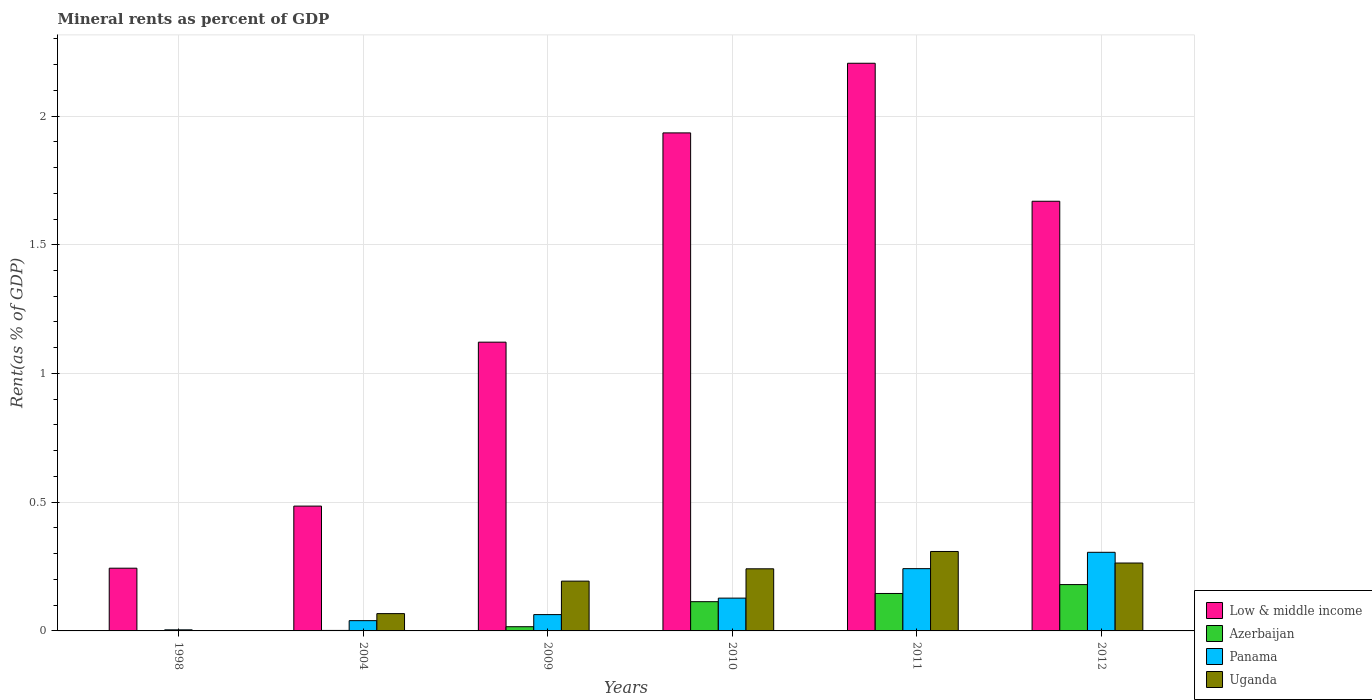Are the number of bars per tick equal to the number of legend labels?
Your answer should be compact. Yes. Are the number of bars on each tick of the X-axis equal?
Your response must be concise. Yes. How many bars are there on the 3rd tick from the left?
Give a very brief answer. 4. What is the label of the 1st group of bars from the left?
Your answer should be compact. 1998. What is the mineral rent in Low & middle income in 2004?
Give a very brief answer. 0.48. Across all years, what is the maximum mineral rent in Panama?
Make the answer very short. 0.31. Across all years, what is the minimum mineral rent in Low & middle income?
Keep it short and to the point. 0.24. What is the total mineral rent in Azerbaijan in the graph?
Keep it short and to the point. 0.46. What is the difference between the mineral rent in Azerbaijan in 2004 and that in 2010?
Your answer should be very brief. -0.11. What is the difference between the mineral rent in Uganda in 2011 and the mineral rent in Low & middle income in 2012?
Keep it short and to the point. -1.36. What is the average mineral rent in Azerbaijan per year?
Provide a succinct answer. 0.08. In the year 2010, what is the difference between the mineral rent in Azerbaijan and mineral rent in Panama?
Give a very brief answer. -0.01. What is the ratio of the mineral rent in Azerbaijan in 2009 to that in 2010?
Provide a succinct answer. 0.14. Is the difference between the mineral rent in Azerbaijan in 1998 and 2010 greater than the difference between the mineral rent in Panama in 1998 and 2010?
Your response must be concise. Yes. What is the difference between the highest and the second highest mineral rent in Azerbaijan?
Offer a very short reply. 0.03. What is the difference between the highest and the lowest mineral rent in Azerbaijan?
Ensure brevity in your answer.  0.18. In how many years, is the mineral rent in Low & middle income greater than the average mineral rent in Low & middle income taken over all years?
Provide a succinct answer. 3. What does the 2nd bar from the left in 2010 represents?
Your answer should be very brief. Azerbaijan. What does the 1st bar from the right in 2011 represents?
Make the answer very short. Uganda. How many years are there in the graph?
Keep it short and to the point. 6. What is the difference between two consecutive major ticks on the Y-axis?
Offer a very short reply. 0.5. Does the graph contain any zero values?
Give a very brief answer. No. Where does the legend appear in the graph?
Make the answer very short. Bottom right. How are the legend labels stacked?
Provide a succinct answer. Vertical. What is the title of the graph?
Offer a terse response. Mineral rents as percent of GDP. Does "Malawi" appear as one of the legend labels in the graph?
Your answer should be very brief. No. What is the label or title of the Y-axis?
Provide a succinct answer. Rent(as % of GDP). What is the Rent(as % of GDP) in Low & middle income in 1998?
Your response must be concise. 0.24. What is the Rent(as % of GDP) of Azerbaijan in 1998?
Give a very brief answer. 0. What is the Rent(as % of GDP) of Panama in 1998?
Your answer should be very brief. 0. What is the Rent(as % of GDP) in Uganda in 1998?
Provide a short and direct response. 3.73694206195052e-5. What is the Rent(as % of GDP) of Low & middle income in 2004?
Ensure brevity in your answer.  0.48. What is the Rent(as % of GDP) of Azerbaijan in 2004?
Your response must be concise. 0. What is the Rent(as % of GDP) of Panama in 2004?
Give a very brief answer. 0.04. What is the Rent(as % of GDP) in Uganda in 2004?
Offer a very short reply. 0.07. What is the Rent(as % of GDP) in Low & middle income in 2009?
Offer a very short reply. 1.12. What is the Rent(as % of GDP) of Azerbaijan in 2009?
Offer a very short reply. 0.02. What is the Rent(as % of GDP) of Panama in 2009?
Make the answer very short. 0.06. What is the Rent(as % of GDP) of Uganda in 2009?
Your answer should be very brief. 0.19. What is the Rent(as % of GDP) of Low & middle income in 2010?
Your answer should be very brief. 1.93. What is the Rent(as % of GDP) of Azerbaijan in 2010?
Make the answer very short. 0.11. What is the Rent(as % of GDP) in Panama in 2010?
Your answer should be very brief. 0.13. What is the Rent(as % of GDP) in Uganda in 2010?
Offer a very short reply. 0.24. What is the Rent(as % of GDP) in Low & middle income in 2011?
Your answer should be compact. 2.21. What is the Rent(as % of GDP) in Azerbaijan in 2011?
Give a very brief answer. 0.15. What is the Rent(as % of GDP) of Panama in 2011?
Make the answer very short. 0.24. What is the Rent(as % of GDP) of Uganda in 2011?
Ensure brevity in your answer.  0.31. What is the Rent(as % of GDP) in Low & middle income in 2012?
Ensure brevity in your answer.  1.67. What is the Rent(as % of GDP) in Azerbaijan in 2012?
Provide a short and direct response. 0.18. What is the Rent(as % of GDP) of Panama in 2012?
Keep it short and to the point. 0.31. What is the Rent(as % of GDP) of Uganda in 2012?
Your answer should be very brief. 0.26. Across all years, what is the maximum Rent(as % of GDP) in Low & middle income?
Your answer should be compact. 2.21. Across all years, what is the maximum Rent(as % of GDP) of Azerbaijan?
Offer a terse response. 0.18. Across all years, what is the maximum Rent(as % of GDP) of Panama?
Ensure brevity in your answer.  0.31. Across all years, what is the maximum Rent(as % of GDP) in Uganda?
Your response must be concise. 0.31. Across all years, what is the minimum Rent(as % of GDP) of Low & middle income?
Offer a terse response. 0.24. Across all years, what is the minimum Rent(as % of GDP) of Azerbaijan?
Ensure brevity in your answer.  0. Across all years, what is the minimum Rent(as % of GDP) of Panama?
Your response must be concise. 0. Across all years, what is the minimum Rent(as % of GDP) in Uganda?
Your answer should be very brief. 3.73694206195052e-5. What is the total Rent(as % of GDP) of Low & middle income in the graph?
Make the answer very short. 7.66. What is the total Rent(as % of GDP) of Azerbaijan in the graph?
Your response must be concise. 0.46. What is the total Rent(as % of GDP) of Panama in the graph?
Your answer should be very brief. 0.78. What is the total Rent(as % of GDP) in Uganda in the graph?
Your response must be concise. 1.07. What is the difference between the Rent(as % of GDP) of Low & middle income in 1998 and that in 2004?
Offer a terse response. -0.24. What is the difference between the Rent(as % of GDP) in Azerbaijan in 1998 and that in 2004?
Your answer should be very brief. -0. What is the difference between the Rent(as % of GDP) of Panama in 1998 and that in 2004?
Ensure brevity in your answer.  -0.04. What is the difference between the Rent(as % of GDP) of Uganda in 1998 and that in 2004?
Ensure brevity in your answer.  -0.07. What is the difference between the Rent(as % of GDP) in Low & middle income in 1998 and that in 2009?
Your response must be concise. -0.88. What is the difference between the Rent(as % of GDP) in Azerbaijan in 1998 and that in 2009?
Your response must be concise. -0.02. What is the difference between the Rent(as % of GDP) in Panama in 1998 and that in 2009?
Give a very brief answer. -0.06. What is the difference between the Rent(as % of GDP) in Uganda in 1998 and that in 2009?
Offer a very short reply. -0.19. What is the difference between the Rent(as % of GDP) of Low & middle income in 1998 and that in 2010?
Give a very brief answer. -1.69. What is the difference between the Rent(as % of GDP) in Azerbaijan in 1998 and that in 2010?
Your answer should be compact. -0.11. What is the difference between the Rent(as % of GDP) of Panama in 1998 and that in 2010?
Offer a very short reply. -0.12. What is the difference between the Rent(as % of GDP) of Uganda in 1998 and that in 2010?
Your answer should be compact. -0.24. What is the difference between the Rent(as % of GDP) of Low & middle income in 1998 and that in 2011?
Offer a terse response. -1.96. What is the difference between the Rent(as % of GDP) in Azerbaijan in 1998 and that in 2011?
Ensure brevity in your answer.  -0.15. What is the difference between the Rent(as % of GDP) of Panama in 1998 and that in 2011?
Give a very brief answer. -0.24. What is the difference between the Rent(as % of GDP) in Uganda in 1998 and that in 2011?
Your answer should be compact. -0.31. What is the difference between the Rent(as % of GDP) of Low & middle income in 1998 and that in 2012?
Make the answer very short. -1.43. What is the difference between the Rent(as % of GDP) of Azerbaijan in 1998 and that in 2012?
Provide a succinct answer. -0.18. What is the difference between the Rent(as % of GDP) in Panama in 1998 and that in 2012?
Make the answer very short. -0.3. What is the difference between the Rent(as % of GDP) in Uganda in 1998 and that in 2012?
Offer a terse response. -0.26. What is the difference between the Rent(as % of GDP) of Low & middle income in 2004 and that in 2009?
Keep it short and to the point. -0.64. What is the difference between the Rent(as % of GDP) of Azerbaijan in 2004 and that in 2009?
Offer a very short reply. -0.01. What is the difference between the Rent(as % of GDP) in Panama in 2004 and that in 2009?
Ensure brevity in your answer.  -0.02. What is the difference between the Rent(as % of GDP) of Uganda in 2004 and that in 2009?
Offer a terse response. -0.13. What is the difference between the Rent(as % of GDP) in Low & middle income in 2004 and that in 2010?
Give a very brief answer. -1.45. What is the difference between the Rent(as % of GDP) in Azerbaijan in 2004 and that in 2010?
Ensure brevity in your answer.  -0.11. What is the difference between the Rent(as % of GDP) of Panama in 2004 and that in 2010?
Your answer should be compact. -0.09. What is the difference between the Rent(as % of GDP) in Uganda in 2004 and that in 2010?
Give a very brief answer. -0.17. What is the difference between the Rent(as % of GDP) of Low & middle income in 2004 and that in 2011?
Offer a terse response. -1.72. What is the difference between the Rent(as % of GDP) of Azerbaijan in 2004 and that in 2011?
Offer a terse response. -0.14. What is the difference between the Rent(as % of GDP) in Panama in 2004 and that in 2011?
Provide a short and direct response. -0.2. What is the difference between the Rent(as % of GDP) of Uganda in 2004 and that in 2011?
Offer a terse response. -0.24. What is the difference between the Rent(as % of GDP) of Low & middle income in 2004 and that in 2012?
Your response must be concise. -1.18. What is the difference between the Rent(as % of GDP) of Azerbaijan in 2004 and that in 2012?
Your answer should be compact. -0.18. What is the difference between the Rent(as % of GDP) in Panama in 2004 and that in 2012?
Give a very brief answer. -0.27. What is the difference between the Rent(as % of GDP) in Uganda in 2004 and that in 2012?
Provide a succinct answer. -0.2. What is the difference between the Rent(as % of GDP) of Low & middle income in 2009 and that in 2010?
Keep it short and to the point. -0.81. What is the difference between the Rent(as % of GDP) in Azerbaijan in 2009 and that in 2010?
Offer a terse response. -0.1. What is the difference between the Rent(as % of GDP) in Panama in 2009 and that in 2010?
Give a very brief answer. -0.06. What is the difference between the Rent(as % of GDP) of Uganda in 2009 and that in 2010?
Ensure brevity in your answer.  -0.05. What is the difference between the Rent(as % of GDP) in Low & middle income in 2009 and that in 2011?
Keep it short and to the point. -1.08. What is the difference between the Rent(as % of GDP) in Azerbaijan in 2009 and that in 2011?
Keep it short and to the point. -0.13. What is the difference between the Rent(as % of GDP) in Panama in 2009 and that in 2011?
Give a very brief answer. -0.18. What is the difference between the Rent(as % of GDP) in Uganda in 2009 and that in 2011?
Your answer should be very brief. -0.12. What is the difference between the Rent(as % of GDP) of Low & middle income in 2009 and that in 2012?
Your answer should be very brief. -0.55. What is the difference between the Rent(as % of GDP) of Azerbaijan in 2009 and that in 2012?
Give a very brief answer. -0.16. What is the difference between the Rent(as % of GDP) in Panama in 2009 and that in 2012?
Your answer should be very brief. -0.24. What is the difference between the Rent(as % of GDP) of Uganda in 2009 and that in 2012?
Offer a terse response. -0.07. What is the difference between the Rent(as % of GDP) of Low & middle income in 2010 and that in 2011?
Keep it short and to the point. -0.27. What is the difference between the Rent(as % of GDP) in Azerbaijan in 2010 and that in 2011?
Your answer should be compact. -0.03. What is the difference between the Rent(as % of GDP) of Panama in 2010 and that in 2011?
Keep it short and to the point. -0.11. What is the difference between the Rent(as % of GDP) of Uganda in 2010 and that in 2011?
Give a very brief answer. -0.07. What is the difference between the Rent(as % of GDP) of Low & middle income in 2010 and that in 2012?
Give a very brief answer. 0.27. What is the difference between the Rent(as % of GDP) in Azerbaijan in 2010 and that in 2012?
Ensure brevity in your answer.  -0.07. What is the difference between the Rent(as % of GDP) in Panama in 2010 and that in 2012?
Your answer should be compact. -0.18. What is the difference between the Rent(as % of GDP) of Uganda in 2010 and that in 2012?
Keep it short and to the point. -0.02. What is the difference between the Rent(as % of GDP) in Low & middle income in 2011 and that in 2012?
Offer a very short reply. 0.54. What is the difference between the Rent(as % of GDP) in Azerbaijan in 2011 and that in 2012?
Offer a very short reply. -0.03. What is the difference between the Rent(as % of GDP) in Panama in 2011 and that in 2012?
Offer a very short reply. -0.06. What is the difference between the Rent(as % of GDP) of Uganda in 2011 and that in 2012?
Your response must be concise. 0.04. What is the difference between the Rent(as % of GDP) in Low & middle income in 1998 and the Rent(as % of GDP) in Azerbaijan in 2004?
Provide a succinct answer. 0.24. What is the difference between the Rent(as % of GDP) of Low & middle income in 1998 and the Rent(as % of GDP) of Panama in 2004?
Provide a short and direct response. 0.2. What is the difference between the Rent(as % of GDP) of Low & middle income in 1998 and the Rent(as % of GDP) of Uganda in 2004?
Provide a short and direct response. 0.18. What is the difference between the Rent(as % of GDP) of Azerbaijan in 1998 and the Rent(as % of GDP) of Panama in 2004?
Ensure brevity in your answer.  -0.04. What is the difference between the Rent(as % of GDP) of Azerbaijan in 1998 and the Rent(as % of GDP) of Uganda in 2004?
Your answer should be very brief. -0.07. What is the difference between the Rent(as % of GDP) of Panama in 1998 and the Rent(as % of GDP) of Uganda in 2004?
Make the answer very short. -0.06. What is the difference between the Rent(as % of GDP) of Low & middle income in 1998 and the Rent(as % of GDP) of Azerbaijan in 2009?
Make the answer very short. 0.23. What is the difference between the Rent(as % of GDP) of Low & middle income in 1998 and the Rent(as % of GDP) of Panama in 2009?
Give a very brief answer. 0.18. What is the difference between the Rent(as % of GDP) of Low & middle income in 1998 and the Rent(as % of GDP) of Uganda in 2009?
Your response must be concise. 0.05. What is the difference between the Rent(as % of GDP) in Azerbaijan in 1998 and the Rent(as % of GDP) in Panama in 2009?
Make the answer very short. -0.06. What is the difference between the Rent(as % of GDP) in Azerbaijan in 1998 and the Rent(as % of GDP) in Uganda in 2009?
Provide a succinct answer. -0.19. What is the difference between the Rent(as % of GDP) in Panama in 1998 and the Rent(as % of GDP) in Uganda in 2009?
Keep it short and to the point. -0.19. What is the difference between the Rent(as % of GDP) of Low & middle income in 1998 and the Rent(as % of GDP) of Azerbaijan in 2010?
Your response must be concise. 0.13. What is the difference between the Rent(as % of GDP) in Low & middle income in 1998 and the Rent(as % of GDP) in Panama in 2010?
Offer a terse response. 0.12. What is the difference between the Rent(as % of GDP) in Low & middle income in 1998 and the Rent(as % of GDP) in Uganda in 2010?
Provide a succinct answer. 0. What is the difference between the Rent(as % of GDP) in Azerbaijan in 1998 and the Rent(as % of GDP) in Panama in 2010?
Provide a short and direct response. -0.13. What is the difference between the Rent(as % of GDP) in Azerbaijan in 1998 and the Rent(as % of GDP) in Uganda in 2010?
Make the answer very short. -0.24. What is the difference between the Rent(as % of GDP) of Panama in 1998 and the Rent(as % of GDP) of Uganda in 2010?
Your answer should be very brief. -0.24. What is the difference between the Rent(as % of GDP) in Low & middle income in 1998 and the Rent(as % of GDP) in Azerbaijan in 2011?
Your answer should be very brief. 0.1. What is the difference between the Rent(as % of GDP) of Low & middle income in 1998 and the Rent(as % of GDP) of Panama in 2011?
Keep it short and to the point. 0. What is the difference between the Rent(as % of GDP) of Low & middle income in 1998 and the Rent(as % of GDP) of Uganda in 2011?
Offer a very short reply. -0.06. What is the difference between the Rent(as % of GDP) in Azerbaijan in 1998 and the Rent(as % of GDP) in Panama in 2011?
Offer a very short reply. -0.24. What is the difference between the Rent(as % of GDP) of Azerbaijan in 1998 and the Rent(as % of GDP) of Uganda in 2011?
Keep it short and to the point. -0.31. What is the difference between the Rent(as % of GDP) in Panama in 1998 and the Rent(as % of GDP) in Uganda in 2011?
Offer a terse response. -0.3. What is the difference between the Rent(as % of GDP) in Low & middle income in 1998 and the Rent(as % of GDP) in Azerbaijan in 2012?
Offer a terse response. 0.06. What is the difference between the Rent(as % of GDP) of Low & middle income in 1998 and the Rent(as % of GDP) of Panama in 2012?
Keep it short and to the point. -0.06. What is the difference between the Rent(as % of GDP) in Low & middle income in 1998 and the Rent(as % of GDP) in Uganda in 2012?
Your answer should be compact. -0.02. What is the difference between the Rent(as % of GDP) of Azerbaijan in 1998 and the Rent(as % of GDP) of Panama in 2012?
Your answer should be compact. -0.3. What is the difference between the Rent(as % of GDP) of Azerbaijan in 1998 and the Rent(as % of GDP) of Uganda in 2012?
Make the answer very short. -0.26. What is the difference between the Rent(as % of GDP) in Panama in 1998 and the Rent(as % of GDP) in Uganda in 2012?
Provide a short and direct response. -0.26. What is the difference between the Rent(as % of GDP) in Low & middle income in 2004 and the Rent(as % of GDP) in Azerbaijan in 2009?
Keep it short and to the point. 0.47. What is the difference between the Rent(as % of GDP) in Low & middle income in 2004 and the Rent(as % of GDP) in Panama in 2009?
Give a very brief answer. 0.42. What is the difference between the Rent(as % of GDP) in Low & middle income in 2004 and the Rent(as % of GDP) in Uganda in 2009?
Your response must be concise. 0.29. What is the difference between the Rent(as % of GDP) of Azerbaijan in 2004 and the Rent(as % of GDP) of Panama in 2009?
Offer a terse response. -0.06. What is the difference between the Rent(as % of GDP) of Azerbaijan in 2004 and the Rent(as % of GDP) of Uganda in 2009?
Provide a short and direct response. -0.19. What is the difference between the Rent(as % of GDP) of Panama in 2004 and the Rent(as % of GDP) of Uganda in 2009?
Offer a terse response. -0.15. What is the difference between the Rent(as % of GDP) of Low & middle income in 2004 and the Rent(as % of GDP) of Azerbaijan in 2010?
Make the answer very short. 0.37. What is the difference between the Rent(as % of GDP) of Low & middle income in 2004 and the Rent(as % of GDP) of Panama in 2010?
Your response must be concise. 0.36. What is the difference between the Rent(as % of GDP) in Low & middle income in 2004 and the Rent(as % of GDP) in Uganda in 2010?
Make the answer very short. 0.24. What is the difference between the Rent(as % of GDP) in Azerbaijan in 2004 and the Rent(as % of GDP) in Panama in 2010?
Provide a succinct answer. -0.13. What is the difference between the Rent(as % of GDP) of Azerbaijan in 2004 and the Rent(as % of GDP) of Uganda in 2010?
Offer a terse response. -0.24. What is the difference between the Rent(as % of GDP) of Panama in 2004 and the Rent(as % of GDP) of Uganda in 2010?
Your answer should be very brief. -0.2. What is the difference between the Rent(as % of GDP) in Low & middle income in 2004 and the Rent(as % of GDP) in Azerbaijan in 2011?
Give a very brief answer. 0.34. What is the difference between the Rent(as % of GDP) of Low & middle income in 2004 and the Rent(as % of GDP) of Panama in 2011?
Keep it short and to the point. 0.24. What is the difference between the Rent(as % of GDP) in Low & middle income in 2004 and the Rent(as % of GDP) in Uganda in 2011?
Provide a succinct answer. 0.18. What is the difference between the Rent(as % of GDP) in Azerbaijan in 2004 and the Rent(as % of GDP) in Panama in 2011?
Your answer should be compact. -0.24. What is the difference between the Rent(as % of GDP) in Azerbaijan in 2004 and the Rent(as % of GDP) in Uganda in 2011?
Provide a succinct answer. -0.31. What is the difference between the Rent(as % of GDP) of Panama in 2004 and the Rent(as % of GDP) of Uganda in 2011?
Keep it short and to the point. -0.27. What is the difference between the Rent(as % of GDP) of Low & middle income in 2004 and the Rent(as % of GDP) of Azerbaijan in 2012?
Offer a very short reply. 0.3. What is the difference between the Rent(as % of GDP) in Low & middle income in 2004 and the Rent(as % of GDP) in Panama in 2012?
Your answer should be compact. 0.18. What is the difference between the Rent(as % of GDP) in Low & middle income in 2004 and the Rent(as % of GDP) in Uganda in 2012?
Keep it short and to the point. 0.22. What is the difference between the Rent(as % of GDP) of Azerbaijan in 2004 and the Rent(as % of GDP) of Panama in 2012?
Give a very brief answer. -0.3. What is the difference between the Rent(as % of GDP) of Azerbaijan in 2004 and the Rent(as % of GDP) of Uganda in 2012?
Offer a very short reply. -0.26. What is the difference between the Rent(as % of GDP) in Panama in 2004 and the Rent(as % of GDP) in Uganda in 2012?
Provide a succinct answer. -0.22. What is the difference between the Rent(as % of GDP) in Low & middle income in 2009 and the Rent(as % of GDP) in Azerbaijan in 2010?
Offer a terse response. 1.01. What is the difference between the Rent(as % of GDP) in Low & middle income in 2009 and the Rent(as % of GDP) in Uganda in 2010?
Your response must be concise. 0.88. What is the difference between the Rent(as % of GDP) in Azerbaijan in 2009 and the Rent(as % of GDP) in Panama in 2010?
Give a very brief answer. -0.11. What is the difference between the Rent(as % of GDP) of Azerbaijan in 2009 and the Rent(as % of GDP) of Uganda in 2010?
Offer a very short reply. -0.22. What is the difference between the Rent(as % of GDP) of Panama in 2009 and the Rent(as % of GDP) of Uganda in 2010?
Your answer should be very brief. -0.18. What is the difference between the Rent(as % of GDP) of Low & middle income in 2009 and the Rent(as % of GDP) of Azerbaijan in 2011?
Offer a terse response. 0.98. What is the difference between the Rent(as % of GDP) in Low & middle income in 2009 and the Rent(as % of GDP) in Panama in 2011?
Provide a short and direct response. 0.88. What is the difference between the Rent(as % of GDP) in Low & middle income in 2009 and the Rent(as % of GDP) in Uganda in 2011?
Provide a short and direct response. 0.81. What is the difference between the Rent(as % of GDP) of Azerbaijan in 2009 and the Rent(as % of GDP) of Panama in 2011?
Provide a short and direct response. -0.23. What is the difference between the Rent(as % of GDP) of Azerbaijan in 2009 and the Rent(as % of GDP) of Uganda in 2011?
Make the answer very short. -0.29. What is the difference between the Rent(as % of GDP) of Panama in 2009 and the Rent(as % of GDP) of Uganda in 2011?
Your answer should be very brief. -0.25. What is the difference between the Rent(as % of GDP) in Low & middle income in 2009 and the Rent(as % of GDP) in Azerbaijan in 2012?
Ensure brevity in your answer.  0.94. What is the difference between the Rent(as % of GDP) in Low & middle income in 2009 and the Rent(as % of GDP) in Panama in 2012?
Your answer should be compact. 0.82. What is the difference between the Rent(as % of GDP) of Low & middle income in 2009 and the Rent(as % of GDP) of Uganda in 2012?
Ensure brevity in your answer.  0.86. What is the difference between the Rent(as % of GDP) in Azerbaijan in 2009 and the Rent(as % of GDP) in Panama in 2012?
Offer a terse response. -0.29. What is the difference between the Rent(as % of GDP) of Azerbaijan in 2009 and the Rent(as % of GDP) of Uganda in 2012?
Offer a terse response. -0.25. What is the difference between the Rent(as % of GDP) of Panama in 2009 and the Rent(as % of GDP) of Uganda in 2012?
Provide a succinct answer. -0.2. What is the difference between the Rent(as % of GDP) of Low & middle income in 2010 and the Rent(as % of GDP) of Azerbaijan in 2011?
Make the answer very short. 1.79. What is the difference between the Rent(as % of GDP) of Low & middle income in 2010 and the Rent(as % of GDP) of Panama in 2011?
Provide a short and direct response. 1.69. What is the difference between the Rent(as % of GDP) in Low & middle income in 2010 and the Rent(as % of GDP) in Uganda in 2011?
Offer a terse response. 1.63. What is the difference between the Rent(as % of GDP) in Azerbaijan in 2010 and the Rent(as % of GDP) in Panama in 2011?
Keep it short and to the point. -0.13. What is the difference between the Rent(as % of GDP) of Azerbaijan in 2010 and the Rent(as % of GDP) of Uganda in 2011?
Ensure brevity in your answer.  -0.2. What is the difference between the Rent(as % of GDP) in Panama in 2010 and the Rent(as % of GDP) in Uganda in 2011?
Your answer should be very brief. -0.18. What is the difference between the Rent(as % of GDP) of Low & middle income in 2010 and the Rent(as % of GDP) of Azerbaijan in 2012?
Keep it short and to the point. 1.75. What is the difference between the Rent(as % of GDP) in Low & middle income in 2010 and the Rent(as % of GDP) in Panama in 2012?
Offer a terse response. 1.63. What is the difference between the Rent(as % of GDP) of Low & middle income in 2010 and the Rent(as % of GDP) of Uganda in 2012?
Provide a succinct answer. 1.67. What is the difference between the Rent(as % of GDP) in Azerbaijan in 2010 and the Rent(as % of GDP) in Panama in 2012?
Your response must be concise. -0.19. What is the difference between the Rent(as % of GDP) in Azerbaijan in 2010 and the Rent(as % of GDP) in Uganda in 2012?
Make the answer very short. -0.15. What is the difference between the Rent(as % of GDP) of Panama in 2010 and the Rent(as % of GDP) of Uganda in 2012?
Give a very brief answer. -0.14. What is the difference between the Rent(as % of GDP) in Low & middle income in 2011 and the Rent(as % of GDP) in Azerbaijan in 2012?
Ensure brevity in your answer.  2.03. What is the difference between the Rent(as % of GDP) of Low & middle income in 2011 and the Rent(as % of GDP) of Panama in 2012?
Provide a short and direct response. 1.9. What is the difference between the Rent(as % of GDP) of Low & middle income in 2011 and the Rent(as % of GDP) of Uganda in 2012?
Provide a short and direct response. 1.94. What is the difference between the Rent(as % of GDP) in Azerbaijan in 2011 and the Rent(as % of GDP) in Panama in 2012?
Give a very brief answer. -0.16. What is the difference between the Rent(as % of GDP) of Azerbaijan in 2011 and the Rent(as % of GDP) of Uganda in 2012?
Ensure brevity in your answer.  -0.12. What is the difference between the Rent(as % of GDP) of Panama in 2011 and the Rent(as % of GDP) of Uganda in 2012?
Ensure brevity in your answer.  -0.02. What is the average Rent(as % of GDP) in Low & middle income per year?
Keep it short and to the point. 1.28. What is the average Rent(as % of GDP) in Azerbaijan per year?
Offer a terse response. 0.08. What is the average Rent(as % of GDP) in Panama per year?
Your answer should be compact. 0.13. What is the average Rent(as % of GDP) in Uganda per year?
Your response must be concise. 0.18. In the year 1998, what is the difference between the Rent(as % of GDP) of Low & middle income and Rent(as % of GDP) of Azerbaijan?
Provide a succinct answer. 0.24. In the year 1998, what is the difference between the Rent(as % of GDP) in Low & middle income and Rent(as % of GDP) in Panama?
Offer a terse response. 0.24. In the year 1998, what is the difference between the Rent(as % of GDP) in Low & middle income and Rent(as % of GDP) in Uganda?
Offer a very short reply. 0.24. In the year 1998, what is the difference between the Rent(as % of GDP) in Azerbaijan and Rent(as % of GDP) in Panama?
Offer a very short reply. -0. In the year 1998, what is the difference between the Rent(as % of GDP) in Azerbaijan and Rent(as % of GDP) in Uganda?
Your answer should be compact. 0. In the year 1998, what is the difference between the Rent(as % of GDP) in Panama and Rent(as % of GDP) in Uganda?
Ensure brevity in your answer.  0. In the year 2004, what is the difference between the Rent(as % of GDP) of Low & middle income and Rent(as % of GDP) of Azerbaijan?
Offer a very short reply. 0.48. In the year 2004, what is the difference between the Rent(as % of GDP) of Low & middle income and Rent(as % of GDP) of Panama?
Offer a terse response. 0.44. In the year 2004, what is the difference between the Rent(as % of GDP) in Low & middle income and Rent(as % of GDP) in Uganda?
Give a very brief answer. 0.42. In the year 2004, what is the difference between the Rent(as % of GDP) in Azerbaijan and Rent(as % of GDP) in Panama?
Your response must be concise. -0.04. In the year 2004, what is the difference between the Rent(as % of GDP) in Azerbaijan and Rent(as % of GDP) in Uganda?
Your response must be concise. -0.07. In the year 2004, what is the difference between the Rent(as % of GDP) in Panama and Rent(as % of GDP) in Uganda?
Ensure brevity in your answer.  -0.03. In the year 2009, what is the difference between the Rent(as % of GDP) in Low & middle income and Rent(as % of GDP) in Azerbaijan?
Ensure brevity in your answer.  1.11. In the year 2009, what is the difference between the Rent(as % of GDP) in Low & middle income and Rent(as % of GDP) in Panama?
Your answer should be compact. 1.06. In the year 2009, what is the difference between the Rent(as % of GDP) of Low & middle income and Rent(as % of GDP) of Uganda?
Make the answer very short. 0.93. In the year 2009, what is the difference between the Rent(as % of GDP) in Azerbaijan and Rent(as % of GDP) in Panama?
Offer a terse response. -0.05. In the year 2009, what is the difference between the Rent(as % of GDP) of Azerbaijan and Rent(as % of GDP) of Uganda?
Offer a terse response. -0.18. In the year 2009, what is the difference between the Rent(as % of GDP) in Panama and Rent(as % of GDP) in Uganda?
Ensure brevity in your answer.  -0.13. In the year 2010, what is the difference between the Rent(as % of GDP) in Low & middle income and Rent(as % of GDP) in Azerbaijan?
Offer a very short reply. 1.82. In the year 2010, what is the difference between the Rent(as % of GDP) in Low & middle income and Rent(as % of GDP) in Panama?
Provide a short and direct response. 1.81. In the year 2010, what is the difference between the Rent(as % of GDP) of Low & middle income and Rent(as % of GDP) of Uganda?
Offer a terse response. 1.69. In the year 2010, what is the difference between the Rent(as % of GDP) of Azerbaijan and Rent(as % of GDP) of Panama?
Your answer should be very brief. -0.01. In the year 2010, what is the difference between the Rent(as % of GDP) of Azerbaijan and Rent(as % of GDP) of Uganda?
Give a very brief answer. -0.13. In the year 2010, what is the difference between the Rent(as % of GDP) of Panama and Rent(as % of GDP) of Uganda?
Provide a succinct answer. -0.11. In the year 2011, what is the difference between the Rent(as % of GDP) of Low & middle income and Rent(as % of GDP) of Azerbaijan?
Keep it short and to the point. 2.06. In the year 2011, what is the difference between the Rent(as % of GDP) in Low & middle income and Rent(as % of GDP) in Panama?
Offer a very short reply. 1.96. In the year 2011, what is the difference between the Rent(as % of GDP) in Low & middle income and Rent(as % of GDP) in Uganda?
Your response must be concise. 1.9. In the year 2011, what is the difference between the Rent(as % of GDP) in Azerbaijan and Rent(as % of GDP) in Panama?
Your response must be concise. -0.1. In the year 2011, what is the difference between the Rent(as % of GDP) of Azerbaijan and Rent(as % of GDP) of Uganda?
Provide a succinct answer. -0.16. In the year 2011, what is the difference between the Rent(as % of GDP) in Panama and Rent(as % of GDP) in Uganda?
Your answer should be very brief. -0.07. In the year 2012, what is the difference between the Rent(as % of GDP) in Low & middle income and Rent(as % of GDP) in Azerbaijan?
Your answer should be compact. 1.49. In the year 2012, what is the difference between the Rent(as % of GDP) in Low & middle income and Rent(as % of GDP) in Panama?
Offer a very short reply. 1.36. In the year 2012, what is the difference between the Rent(as % of GDP) of Low & middle income and Rent(as % of GDP) of Uganda?
Offer a terse response. 1.41. In the year 2012, what is the difference between the Rent(as % of GDP) of Azerbaijan and Rent(as % of GDP) of Panama?
Give a very brief answer. -0.13. In the year 2012, what is the difference between the Rent(as % of GDP) in Azerbaijan and Rent(as % of GDP) in Uganda?
Ensure brevity in your answer.  -0.08. In the year 2012, what is the difference between the Rent(as % of GDP) in Panama and Rent(as % of GDP) in Uganda?
Keep it short and to the point. 0.04. What is the ratio of the Rent(as % of GDP) of Low & middle income in 1998 to that in 2004?
Provide a succinct answer. 0.5. What is the ratio of the Rent(as % of GDP) in Azerbaijan in 1998 to that in 2004?
Ensure brevity in your answer.  0.21. What is the ratio of the Rent(as % of GDP) of Panama in 1998 to that in 2004?
Keep it short and to the point. 0.11. What is the ratio of the Rent(as % of GDP) in Uganda in 1998 to that in 2004?
Keep it short and to the point. 0. What is the ratio of the Rent(as % of GDP) of Low & middle income in 1998 to that in 2009?
Your answer should be very brief. 0.22. What is the ratio of the Rent(as % of GDP) in Azerbaijan in 1998 to that in 2009?
Offer a very short reply. 0.02. What is the ratio of the Rent(as % of GDP) in Panama in 1998 to that in 2009?
Provide a succinct answer. 0.07. What is the ratio of the Rent(as % of GDP) of Low & middle income in 1998 to that in 2010?
Keep it short and to the point. 0.13. What is the ratio of the Rent(as % of GDP) in Azerbaijan in 1998 to that in 2010?
Give a very brief answer. 0. What is the ratio of the Rent(as % of GDP) in Panama in 1998 to that in 2010?
Your response must be concise. 0.03. What is the ratio of the Rent(as % of GDP) of Low & middle income in 1998 to that in 2011?
Give a very brief answer. 0.11. What is the ratio of the Rent(as % of GDP) of Azerbaijan in 1998 to that in 2011?
Your answer should be compact. 0. What is the ratio of the Rent(as % of GDP) of Panama in 1998 to that in 2011?
Make the answer very short. 0.02. What is the ratio of the Rent(as % of GDP) of Uganda in 1998 to that in 2011?
Provide a succinct answer. 0. What is the ratio of the Rent(as % of GDP) in Low & middle income in 1998 to that in 2012?
Your answer should be compact. 0.15. What is the ratio of the Rent(as % of GDP) of Azerbaijan in 1998 to that in 2012?
Make the answer very short. 0. What is the ratio of the Rent(as % of GDP) of Panama in 1998 to that in 2012?
Make the answer very short. 0.01. What is the ratio of the Rent(as % of GDP) of Low & middle income in 2004 to that in 2009?
Your answer should be compact. 0.43. What is the ratio of the Rent(as % of GDP) of Azerbaijan in 2004 to that in 2009?
Provide a succinct answer. 0.12. What is the ratio of the Rent(as % of GDP) in Panama in 2004 to that in 2009?
Ensure brevity in your answer.  0.63. What is the ratio of the Rent(as % of GDP) in Uganda in 2004 to that in 2009?
Offer a very short reply. 0.35. What is the ratio of the Rent(as % of GDP) in Low & middle income in 2004 to that in 2010?
Keep it short and to the point. 0.25. What is the ratio of the Rent(as % of GDP) in Azerbaijan in 2004 to that in 2010?
Your answer should be compact. 0.02. What is the ratio of the Rent(as % of GDP) in Panama in 2004 to that in 2010?
Provide a succinct answer. 0.31. What is the ratio of the Rent(as % of GDP) of Uganda in 2004 to that in 2010?
Give a very brief answer. 0.28. What is the ratio of the Rent(as % of GDP) of Low & middle income in 2004 to that in 2011?
Keep it short and to the point. 0.22. What is the ratio of the Rent(as % of GDP) in Azerbaijan in 2004 to that in 2011?
Ensure brevity in your answer.  0.01. What is the ratio of the Rent(as % of GDP) in Panama in 2004 to that in 2011?
Ensure brevity in your answer.  0.16. What is the ratio of the Rent(as % of GDP) of Uganda in 2004 to that in 2011?
Keep it short and to the point. 0.22. What is the ratio of the Rent(as % of GDP) of Low & middle income in 2004 to that in 2012?
Your answer should be compact. 0.29. What is the ratio of the Rent(as % of GDP) in Azerbaijan in 2004 to that in 2012?
Make the answer very short. 0.01. What is the ratio of the Rent(as % of GDP) of Panama in 2004 to that in 2012?
Your answer should be compact. 0.13. What is the ratio of the Rent(as % of GDP) of Uganda in 2004 to that in 2012?
Provide a short and direct response. 0.25. What is the ratio of the Rent(as % of GDP) in Low & middle income in 2009 to that in 2010?
Ensure brevity in your answer.  0.58. What is the ratio of the Rent(as % of GDP) in Azerbaijan in 2009 to that in 2010?
Offer a very short reply. 0.14. What is the ratio of the Rent(as % of GDP) in Panama in 2009 to that in 2010?
Provide a succinct answer. 0.5. What is the ratio of the Rent(as % of GDP) in Uganda in 2009 to that in 2010?
Your answer should be very brief. 0.8. What is the ratio of the Rent(as % of GDP) in Low & middle income in 2009 to that in 2011?
Your response must be concise. 0.51. What is the ratio of the Rent(as % of GDP) of Azerbaijan in 2009 to that in 2011?
Keep it short and to the point. 0.11. What is the ratio of the Rent(as % of GDP) in Panama in 2009 to that in 2011?
Make the answer very short. 0.26. What is the ratio of the Rent(as % of GDP) in Uganda in 2009 to that in 2011?
Offer a very short reply. 0.63. What is the ratio of the Rent(as % of GDP) of Low & middle income in 2009 to that in 2012?
Your answer should be very brief. 0.67. What is the ratio of the Rent(as % of GDP) of Azerbaijan in 2009 to that in 2012?
Give a very brief answer. 0.09. What is the ratio of the Rent(as % of GDP) in Panama in 2009 to that in 2012?
Your response must be concise. 0.21. What is the ratio of the Rent(as % of GDP) in Uganda in 2009 to that in 2012?
Provide a succinct answer. 0.73. What is the ratio of the Rent(as % of GDP) in Low & middle income in 2010 to that in 2011?
Make the answer very short. 0.88. What is the ratio of the Rent(as % of GDP) in Azerbaijan in 2010 to that in 2011?
Provide a succinct answer. 0.78. What is the ratio of the Rent(as % of GDP) in Panama in 2010 to that in 2011?
Provide a succinct answer. 0.53. What is the ratio of the Rent(as % of GDP) of Uganda in 2010 to that in 2011?
Provide a short and direct response. 0.78. What is the ratio of the Rent(as % of GDP) of Low & middle income in 2010 to that in 2012?
Give a very brief answer. 1.16. What is the ratio of the Rent(as % of GDP) in Azerbaijan in 2010 to that in 2012?
Your response must be concise. 0.63. What is the ratio of the Rent(as % of GDP) in Panama in 2010 to that in 2012?
Provide a succinct answer. 0.42. What is the ratio of the Rent(as % of GDP) in Uganda in 2010 to that in 2012?
Your answer should be very brief. 0.92. What is the ratio of the Rent(as % of GDP) in Low & middle income in 2011 to that in 2012?
Provide a succinct answer. 1.32. What is the ratio of the Rent(as % of GDP) in Azerbaijan in 2011 to that in 2012?
Offer a very short reply. 0.81. What is the ratio of the Rent(as % of GDP) in Panama in 2011 to that in 2012?
Provide a short and direct response. 0.79. What is the ratio of the Rent(as % of GDP) of Uganda in 2011 to that in 2012?
Your answer should be very brief. 1.17. What is the difference between the highest and the second highest Rent(as % of GDP) in Low & middle income?
Keep it short and to the point. 0.27. What is the difference between the highest and the second highest Rent(as % of GDP) in Azerbaijan?
Keep it short and to the point. 0.03. What is the difference between the highest and the second highest Rent(as % of GDP) of Panama?
Offer a very short reply. 0.06. What is the difference between the highest and the second highest Rent(as % of GDP) of Uganda?
Offer a very short reply. 0.04. What is the difference between the highest and the lowest Rent(as % of GDP) of Low & middle income?
Provide a short and direct response. 1.96. What is the difference between the highest and the lowest Rent(as % of GDP) of Azerbaijan?
Ensure brevity in your answer.  0.18. What is the difference between the highest and the lowest Rent(as % of GDP) of Panama?
Your answer should be very brief. 0.3. What is the difference between the highest and the lowest Rent(as % of GDP) of Uganda?
Make the answer very short. 0.31. 